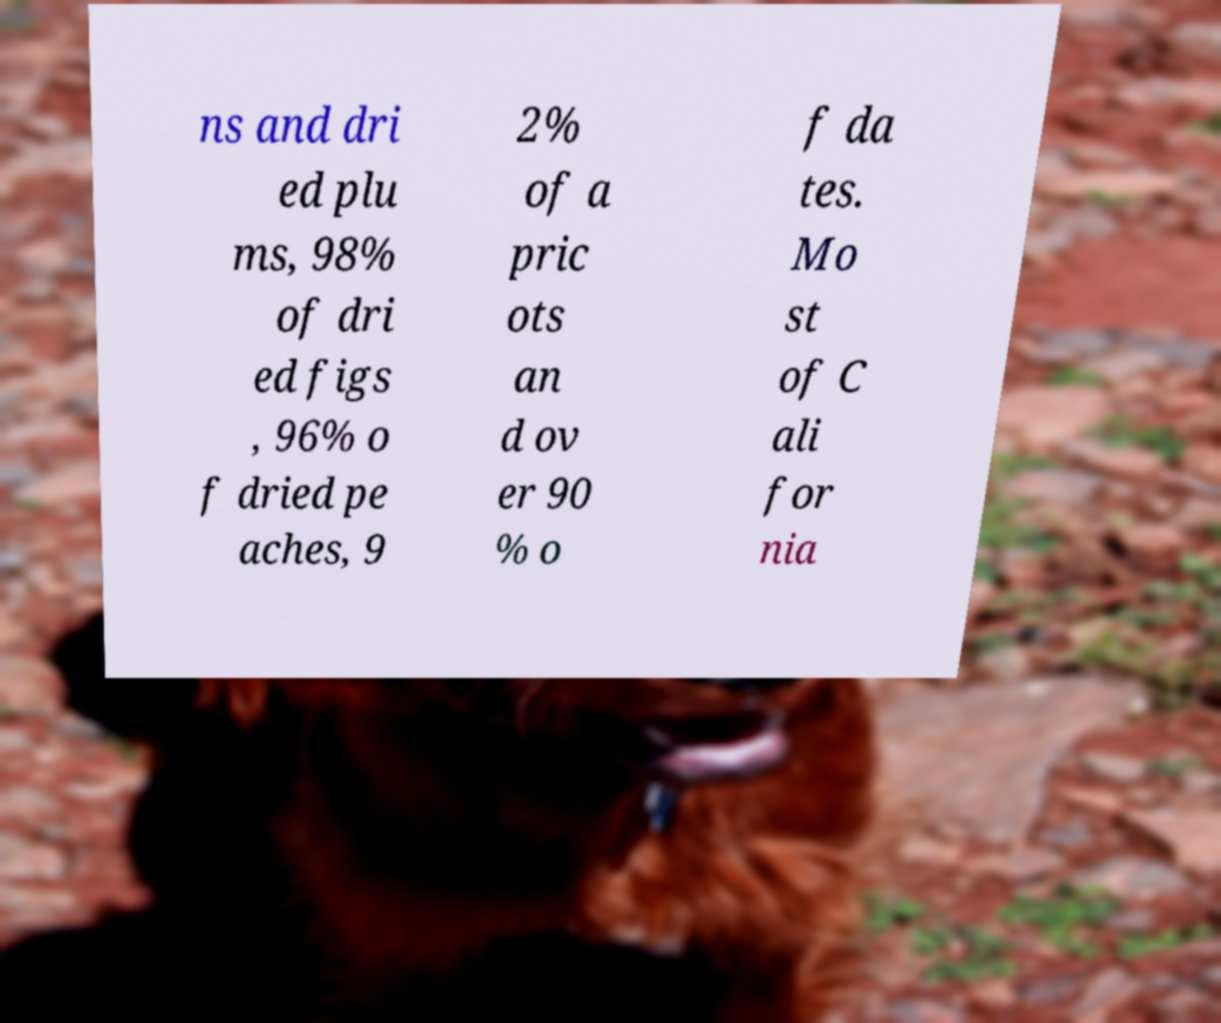Please identify and transcribe the text found in this image. ns and dri ed plu ms, 98% of dri ed figs , 96% o f dried pe aches, 9 2% of a pric ots an d ov er 90 % o f da tes. Mo st of C ali for nia 